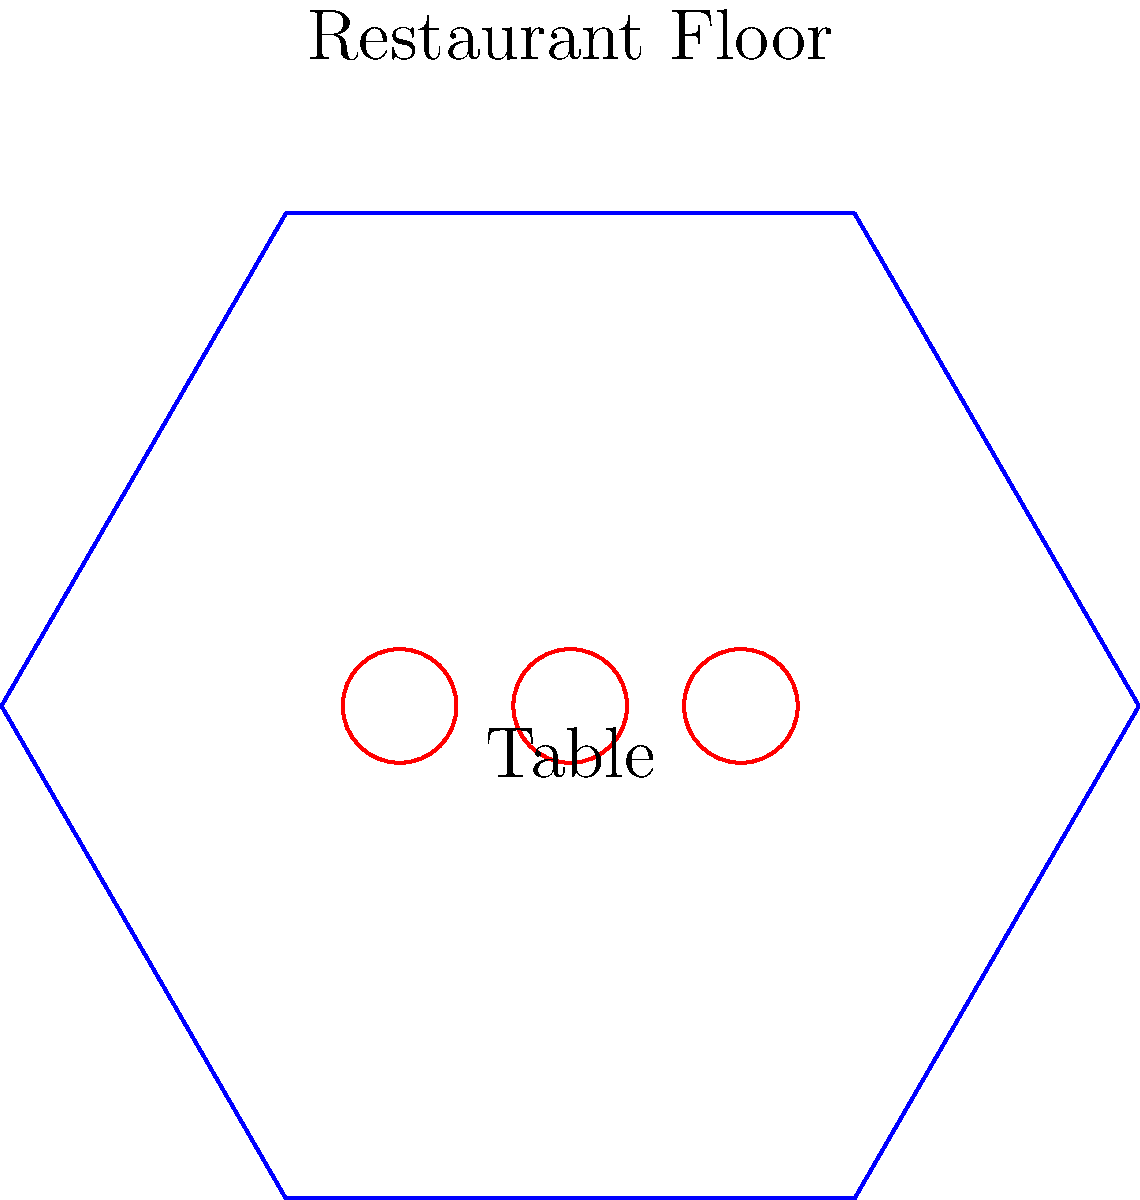A hexagonal-shaped restaurant has a floor area of 150 square meters. The owner wants to maximize the number of circular tables, each with a diameter of 1.2 meters, while maintaining a minimum distance of 0.6 meters between tables for easy movement. What is the maximum number of tables that can be arranged in the restaurant? Let's approach this step-by-step:

1) First, we need to calculate the side length of the hexagonal restaurant:
   Area of a regular hexagon = $\frac{3\sqrt{3}}{2}s^2$, where $s$ is the side length
   $150 = \frac{3\sqrt{3}}{2}s^2$
   $s^2 = \frac{100}{\sqrt{3}} \approx 57.74$
   $s \approx 7.60$ meters

2) Now, we need to consider the space each table occupies:
   - Table diameter: 1.2 meters
   - Minimum distance between tables: 0.6 meters
   So, each table effectively occupies a circular area with diameter 1.8 meters (1.2 + 0.6)

3) The radius of this circular area is 0.9 meters

4) To maximize the number of tables, we can consider a hexagonal packing of these circular areas within our restaurant

5) In a hexagonal packing, the area occupied by each circle is:
   $A_{circle} = 2\sqrt{3}r^2$, where $r$ is the radius of the circular area
   $A_{circle} = 2\sqrt{3}(0.9)^2 \approx 2.80$ square meters

6) The number of tables we can fit is approximately:
   $N = \frac{\text{Area of restaurant}}{\text{Area per table}} = \frac{150}{2.80} \approx 53.57$

7) Since we can't have a fractional number of tables, we round down to 53

Therefore, the maximum number of tables that can be arranged in the restaurant is 53.
Answer: 53 tables 